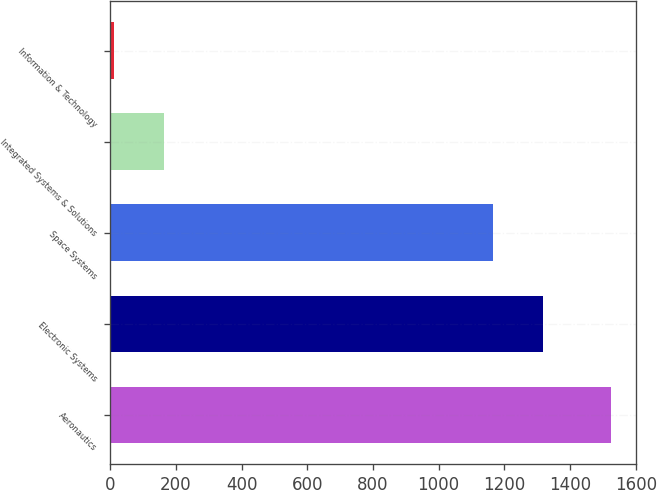Convert chart. <chart><loc_0><loc_0><loc_500><loc_500><bar_chart><fcel>Aeronautics<fcel>Electronic Systems<fcel>Space Systems<fcel>Integrated Systems & Solutions<fcel>Information & Technology<nl><fcel>1526<fcel>1318.3<fcel>1167<fcel>164.3<fcel>13<nl></chart> 